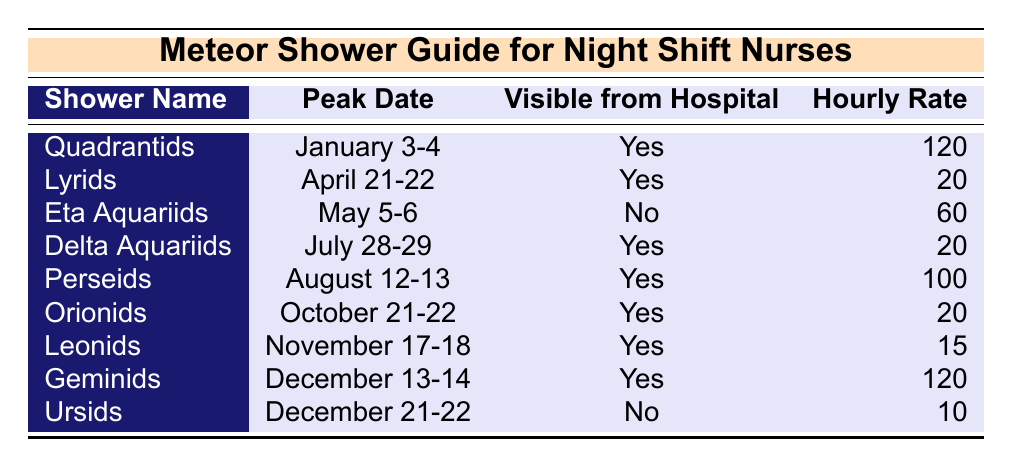What is the peak date for the Perseids meteor shower? The table lists the peak date of the Perseids meteor shower under the "Peak Date" column next to its name. The date is August 12-13.
Answer: August 12-13 How many meteor showers are visible from the hospital? Count the number of "Yes" entries in the "Visible from Hospital" column. There are 6 showers that are marked as visible from the hospital.
Answer: 6 What is the hourly rate for the Quadrantids? The hourly rate for the Quadrantids can be found in the "Hourly Rate" column corresponding to its entry. It shows an hourly rate of 120.
Answer: 120 Are the Ursids visible from the hospital? The table indicates whether the Ursids are visible from the hospital in the "Visible from Hospital" column. It shows "No."
Answer: No What is the average hourly rate of the meteor showers visible from the hospital? First, list the showers visible from the hospital: Quadrantids (120), Lyrids (20), Delta Aquariids (20), Perseids (100), Orionids (20), Leonids (15), and Geminids (120). Sum these rates: 120 + 20 + 20 + 100 + 20 + 15 + 120 = 405. There are 6 showers, so average = 405 / 6 = 67.5.
Answer: 67.5 Which meteor shower has the highest hourly rate? Look at the "Hourly Rate" column and find its maximum value, noting the corresponding shower name. The highest rate is 120, which is shared by the Quadrantids and Geminids.
Answer: Quadrantids and Geminids What is the difference in hourly rate between the Geminids and the Leonids? First, identify the hourly rates from the table: Geminids have an hourly rate of 120 and Leonids have an hourly rate of 15. The difference is 120 - 15 = 105.
Answer: 105 In what month do the Eta Aquariids peak? The peak date for the Eta Aquariids is provided, and it states May 5-6, indicating the month is May.
Answer: May How many meteor showers peak in the second half of the year and are visible from the hospital? The relevant showers are Delta Aquariids (July), Perseids (August), Orionids (October), Leonids (November), and Geminids (December), which totals 5 showers. All of them are marked as "Yes" visible from the hospital.
Answer: 5 Are there any meteor showers in December that are not visible from the hospital? Check the table for December entries; the Ursids (December 21-22) are listed as not visible from the hospital.
Answer: Yes 